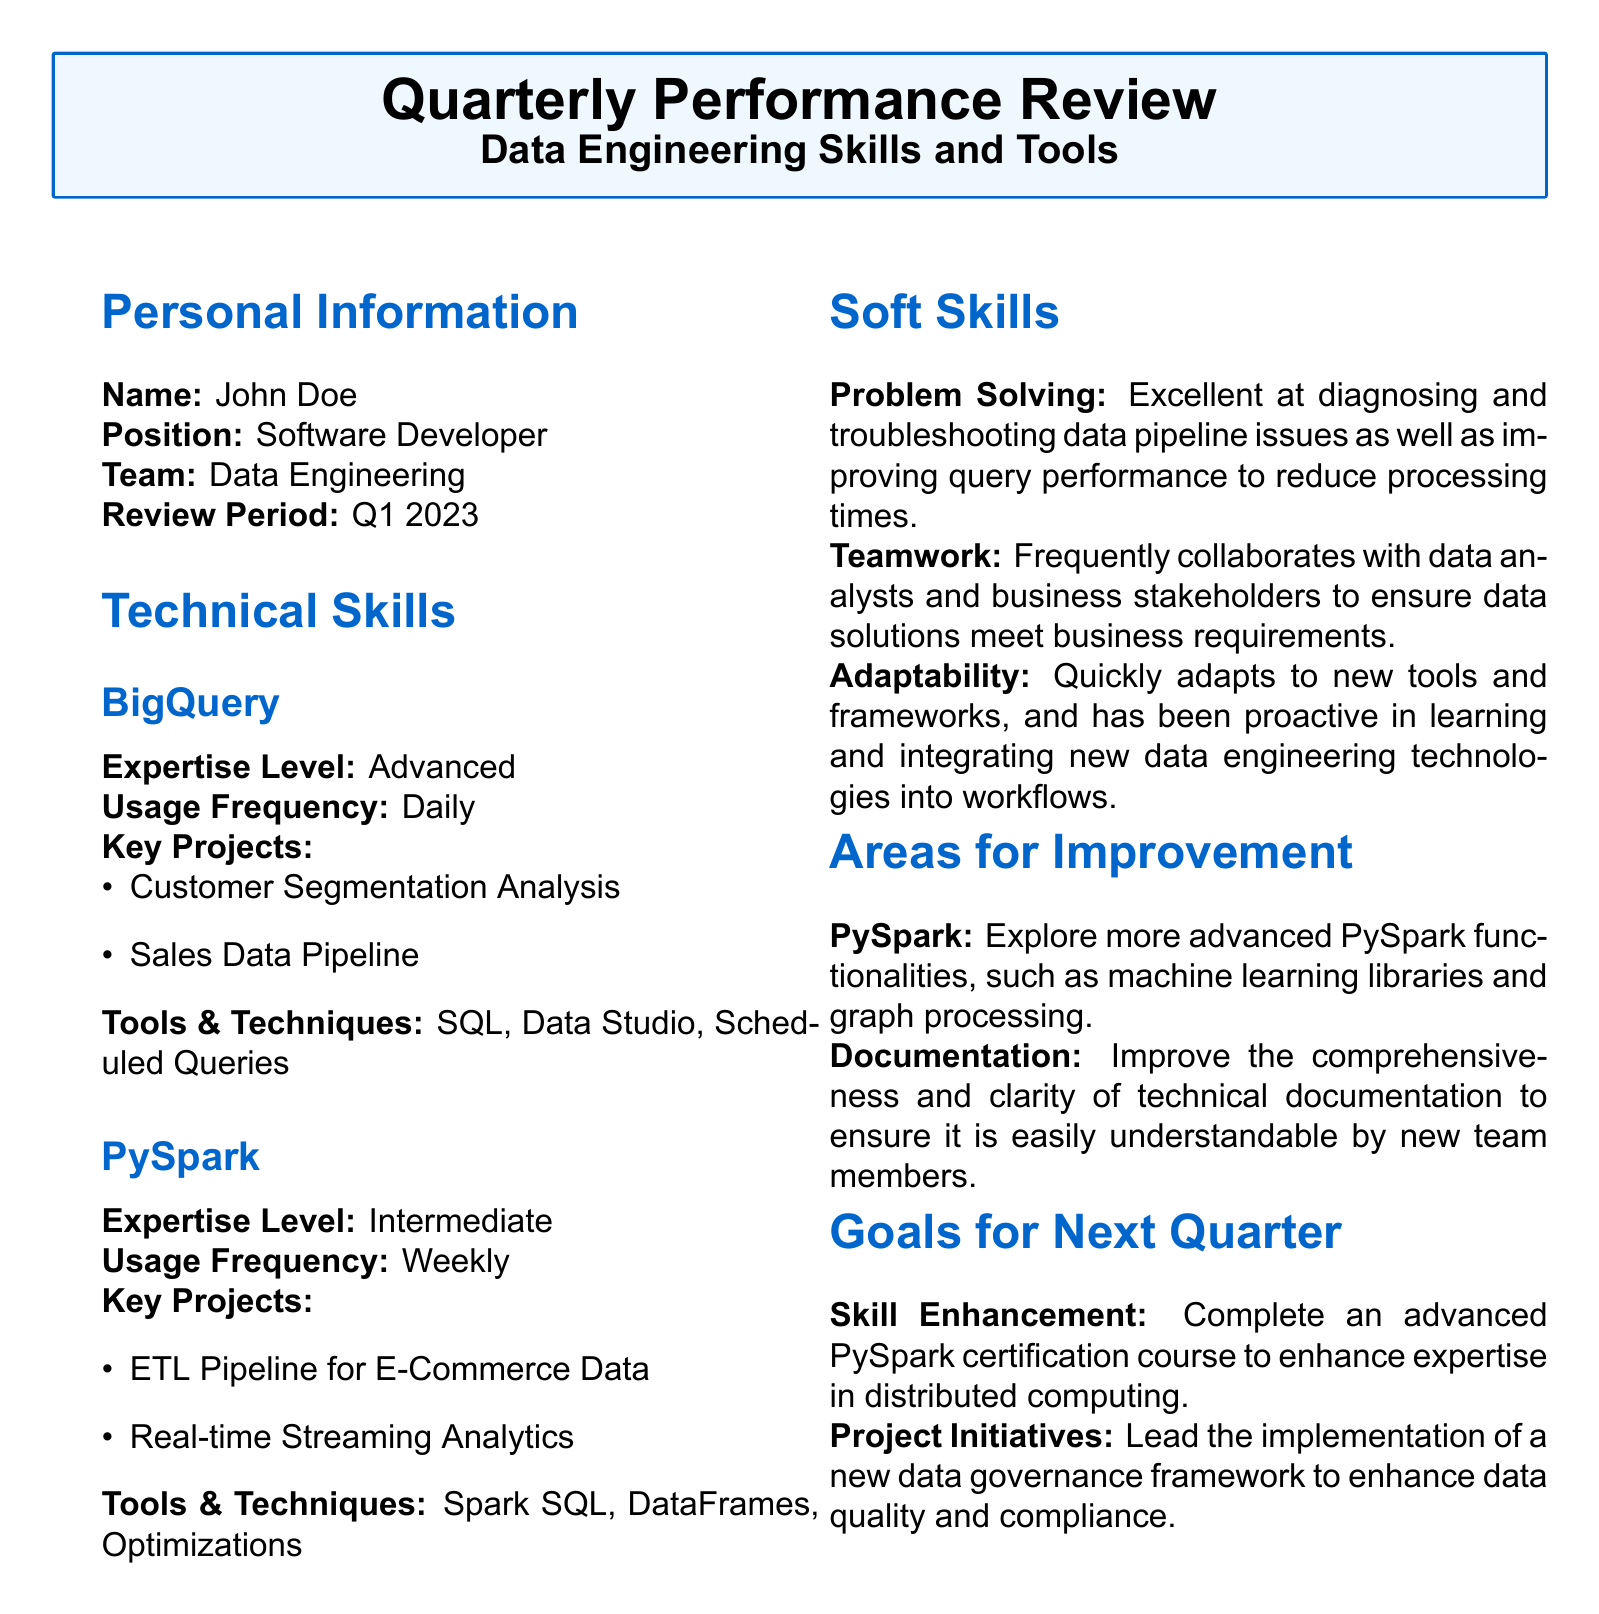What is the name of the individual being reviewed? The name of the individual is listed under Personal Information in the document.
Answer: John Doe What is the position of the individual? The individual's position is specified in the Personal Information section.
Answer: Software Developer What is the review period for the evaluation? The review period is found in the Personal Information section detailing when the review takes place.
Answer: Q1 2023 What is the expertise level for BigQuery? The expertise level for BigQuery is noted in the Technical Skills section.
Answer: Advanced What were the key projects for PySpark? The key projects are listed in the Technical Skills section under PySpark.
Answer: ETL Pipeline for E-Commerce Data, Real-time Streaming Analytics Which soft skill is highlighted for problem solving? The document explains the soft skill associated with problem solving in the Soft Skills section.
Answer: Excellent at diagnosing and troubleshooting data pipeline issues What is one area for improvement mentioned? Areas for improvement are specified in the document, indicating what the individual aims to work on.
Answer: Explore more advanced PySpark functionalities What is one goal for the next quarter? The goals for the next quarter are outlined in the Goals for Next Quarter section, indicating future objectives.
Answer: Complete an advanced PySpark certification course 